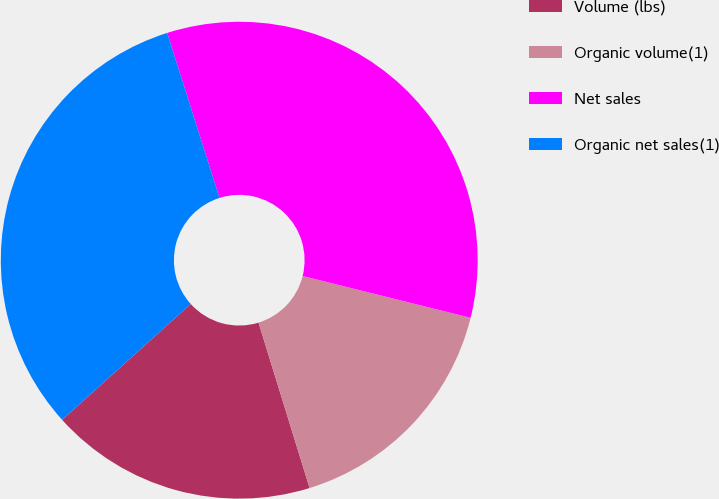Convert chart to OTSL. <chart><loc_0><loc_0><loc_500><loc_500><pie_chart><fcel>Volume (lbs)<fcel>Organic volume(1)<fcel>Net sales<fcel>Organic net sales(1)<nl><fcel>18.09%<fcel>16.35%<fcel>33.77%<fcel>31.79%<nl></chart> 